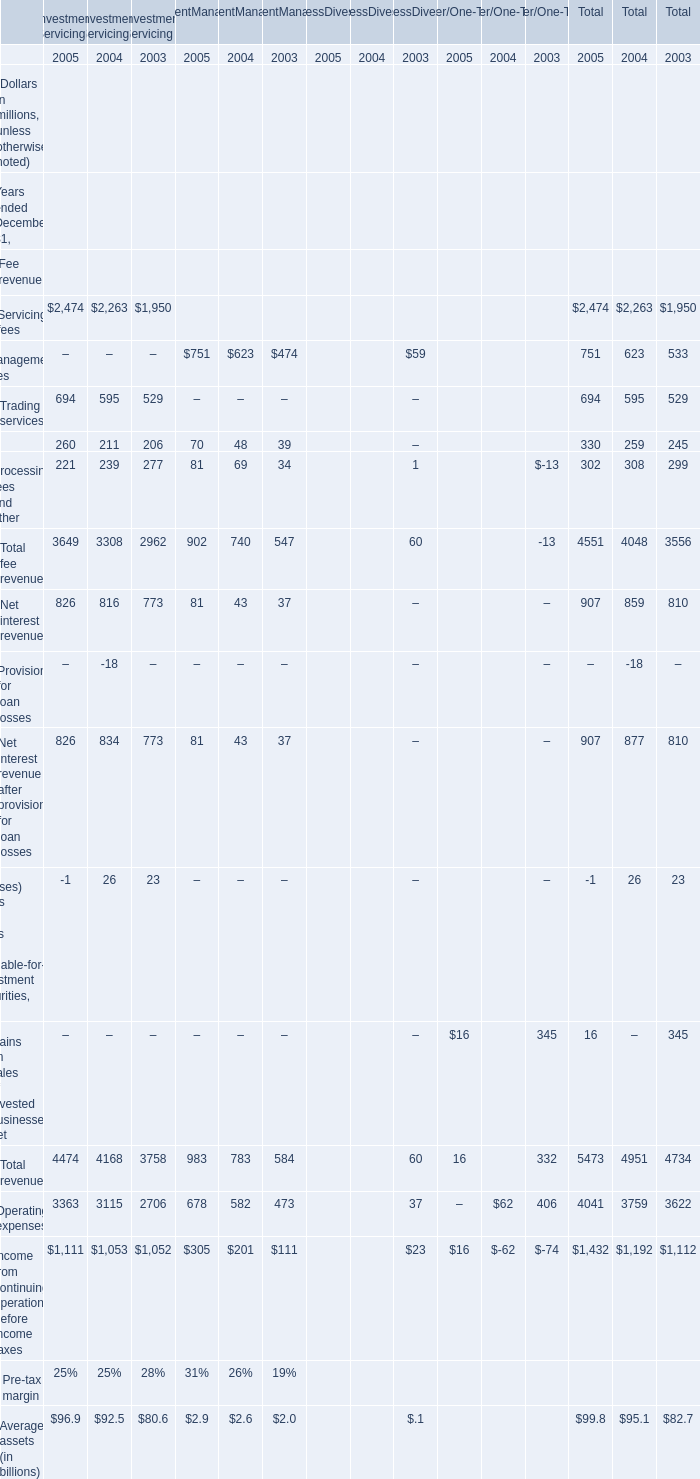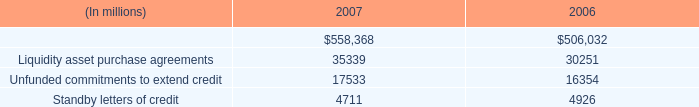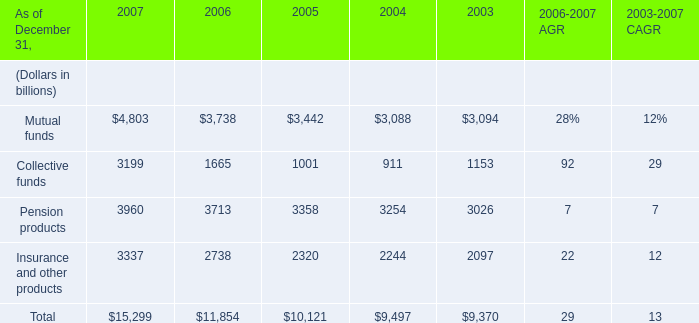What's the increasing rate of the Total fee revenue for Investment Servicing in 2004 ended December 31? 
Computations: ((3308 - 2962) / 2962)
Answer: 0.11681. 